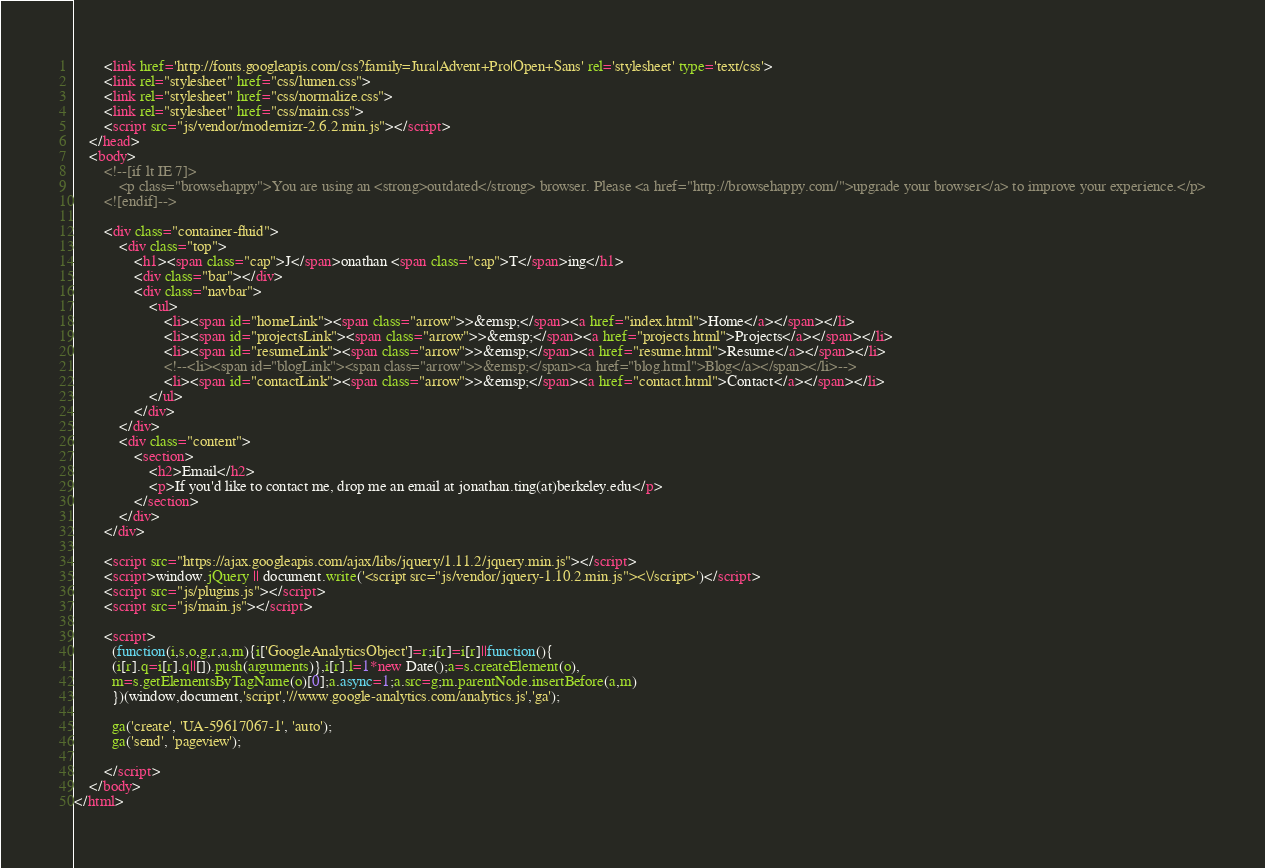<code> <loc_0><loc_0><loc_500><loc_500><_HTML_>        <link href='http://fonts.googleapis.com/css?family=Jura|Advent+Pro|Open+Sans' rel='stylesheet' type='text/css'>
        <link rel="stylesheet" href="css/lumen.css">
        <link rel="stylesheet" href="css/normalize.css">
        <link rel="stylesheet" href="css/main.css">
        <script src="js/vendor/modernizr-2.6.2.min.js"></script>
    </head>
    <body>
        <!--[if lt IE 7]>
            <p class="browsehappy">You are using an <strong>outdated</strong> browser. Please <a href="http://browsehappy.com/">upgrade your browser</a> to improve your experience.</p>
        <![endif]-->

        <div class="container-fluid">
            <div class="top">
                <h1><span class="cap">J</span>onathan <span class="cap">T</span>ing</h1>
                <div class="bar"></div>
                <div class="navbar">
                    <ul>
                        <li><span id="homeLink"><span class="arrow">>&emsp;</span><a href="index.html">Home</a></span></li>
                        <li><span id="projectsLink"><span class="arrow">>&emsp;</span><a href="projects.html">Projects</a></span></li>
                        <li><span id="resumeLink"><span class="arrow">>&emsp;</span><a href="resume.html">Resume</a></span></li>
                        <!--<li><span id="blogLink"><span class="arrow">>&emsp;</span><a href="blog.html">Blog</a></span></li>-->
                        <li><span id="contactLink"><span class="arrow">>&emsp;</span><a href="contact.html">Contact</a></span></li>
                    </ul>
                </div>
            </div>
            <div class="content">
                <section>
                    <h2>Email</h2>
                    <p>If you'd like to contact me, drop me an email at jonathan.ting(at)berkeley.edu</p>
                </section>
            </div>
        </div>

        <script src="https://ajax.googleapis.com/ajax/libs/jquery/1.11.2/jquery.min.js"></script>
        <script>window.jQuery || document.write('<script src="js/vendor/jquery-1.10.2.min.js"><\/script>')</script>
        <script src="js/plugins.js"></script>
        <script src="js/main.js"></script>

        <script>
          (function(i,s,o,g,r,a,m){i['GoogleAnalyticsObject']=r;i[r]=i[r]||function(){
          (i[r].q=i[r].q||[]).push(arguments)},i[r].l=1*new Date();a=s.createElement(o),
          m=s.getElementsByTagName(o)[0];a.async=1;a.src=g;m.parentNode.insertBefore(a,m)
          })(window,document,'script','//www.google-analytics.com/analytics.js','ga');

          ga('create', 'UA-59617067-1', 'auto');
          ga('send', 'pageview');

        </script>
    </body>
</html></code> 